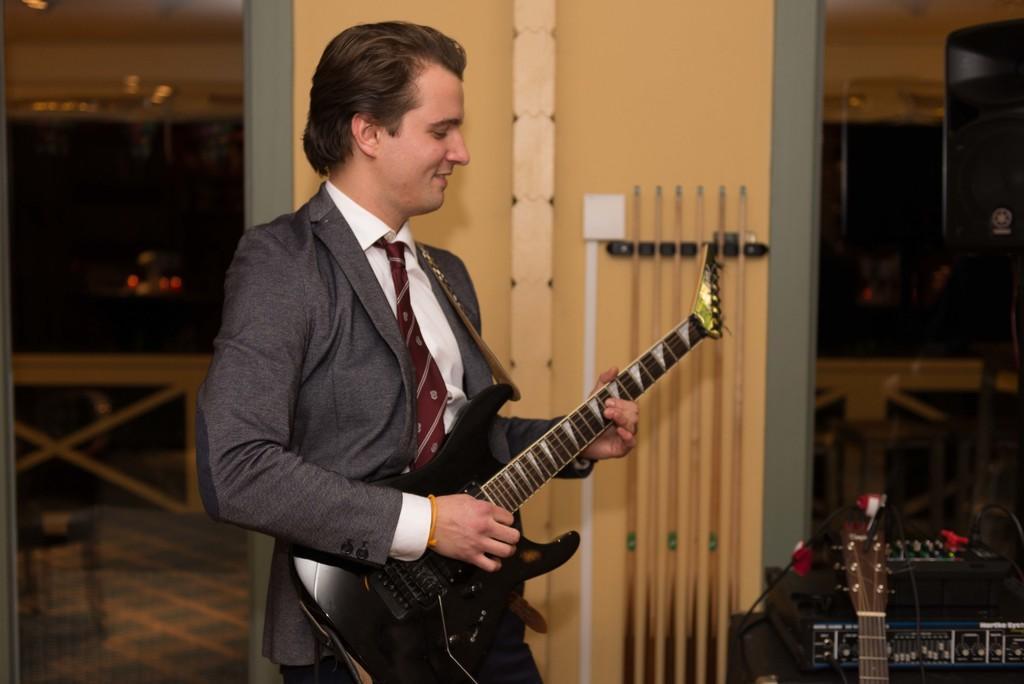Can you describe this image briefly? In this picture there is man playing a guitar in his hands. He is smiling. In the background there is a wall and some snooker sticks placed here. 